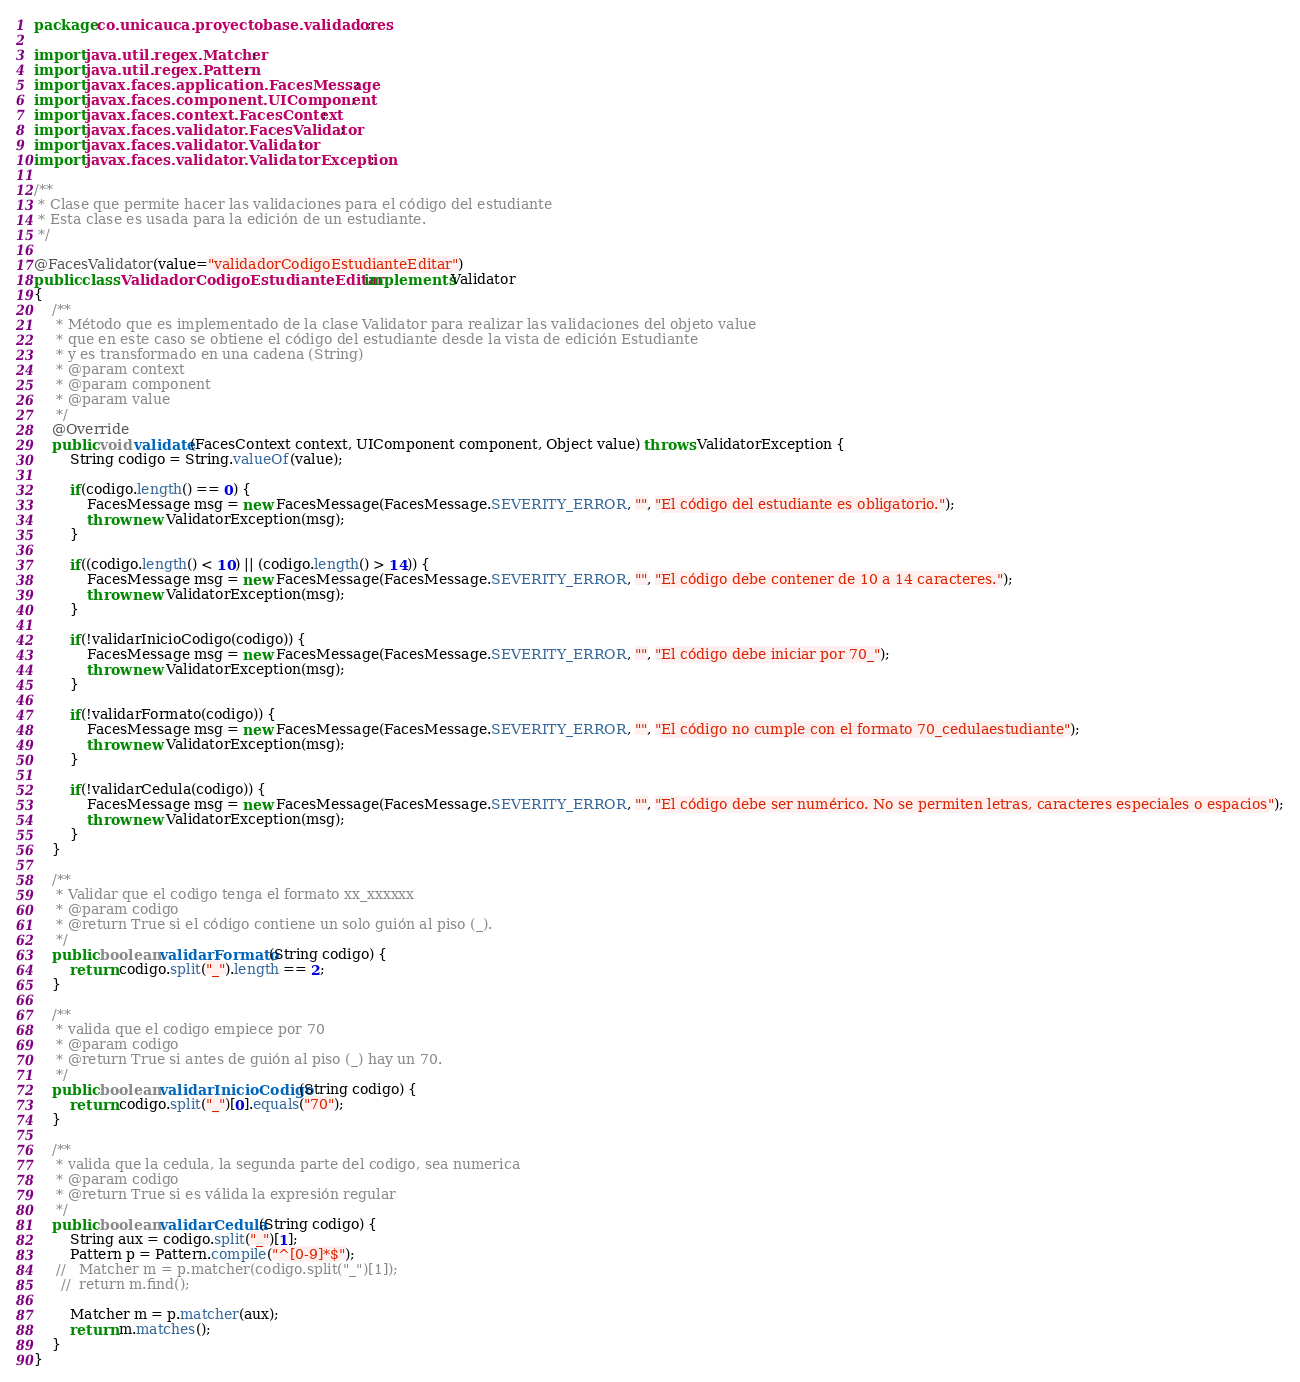Convert code to text. <code><loc_0><loc_0><loc_500><loc_500><_Java_>package co.unicauca.proyectobase.validadores;

import java.util.regex.Matcher;
import java.util.regex.Pattern;
import javax.faces.application.FacesMessage;
import javax.faces.component.UIComponent;
import javax.faces.context.FacesContext;
import javax.faces.validator.FacesValidator;
import javax.faces.validator.Validator;
import javax.faces.validator.ValidatorException;

/**
 * Clase que permite hacer las validaciones para el código del estudiante
 * Esta clase es usada para la edición de un estudiante.
 */

@FacesValidator(value="validadorCodigoEstudianteEditar")
public class ValidadorCodigoEstudianteEditar implements Validator
{    
    /**
     * Método que es implementado de la clase Validator para realizar las validaciones del objeto value
     * que en este caso se obtiene el código del estudiante desde la vista de edición Estudiante
     * y es transformado en una cadena (String)
     * @param context
     * @param component
     * @param value
     */
    @Override
    public void validate(FacesContext context, UIComponent component, Object value) throws ValidatorException {
        String codigo = String.valueOf(value);
        
        if(codigo.length() == 0) {
            FacesMessage msg = new FacesMessage(FacesMessage.SEVERITY_ERROR, "", "El código del estudiante es obligatorio.");
            throw new ValidatorException(msg);  
        }
        
        if((codigo.length() < 10) || (codigo.length() > 14)) {
            FacesMessage msg = new FacesMessage(FacesMessage.SEVERITY_ERROR, "", "El código debe contener de 10 a 14 caracteres.");
            throw new ValidatorException(msg);  
        }
        
        if(!validarInicioCodigo(codigo)) {
            FacesMessage msg = new FacesMessage(FacesMessage.SEVERITY_ERROR, "", "El código debe iniciar por 70_");
            throw new ValidatorException(msg); 
        }
        
        if(!validarFormato(codigo)) {
            FacesMessage msg = new FacesMessage(FacesMessage.SEVERITY_ERROR, "", "El código no cumple con el formato 70_cedulaestudiante");
            throw new ValidatorException(msg); 
        }
        
        if(!validarCedula(codigo)) {
            FacesMessage msg = new FacesMessage(FacesMessage.SEVERITY_ERROR, "", "El código debe ser numérico. No se permiten letras, caracteres especiales o espacios");
            throw new ValidatorException(msg); 
        }
    }
    
    /**
     * Validar que el codigo tenga el formato xx_xxxxxx
     * @param codigo
     * @return True si el código contiene un solo guión al piso (_).
     */
    public boolean validarFormato(String codigo) {
        return codigo.split("_").length == 2;
    }
    
    /**
     * valida que el codigo empiece por 70
     * @param codigo
     * @return True si antes de guión al piso (_) hay un 70.
     */
    public boolean validarInicioCodigo(String codigo) {
        return codigo.split("_")[0].equals("70");
    }
    
    /**
     * valida que la cedula, la segunda parte del codigo, sea numerica
     * @param codigo
     * @return True si es válida la expresión regular
     */
    public boolean validarCedula(String codigo) {
        String aux = codigo.split("_")[1];
        Pattern p = Pattern.compile("^[0-9]*$");
     //   Matcher m = p.matcher(codigo.split("_")[1]);
      //  return m.find();
        
        Matcher m = p.matcher(aux);
        return m.matches();
    }
}</code> 